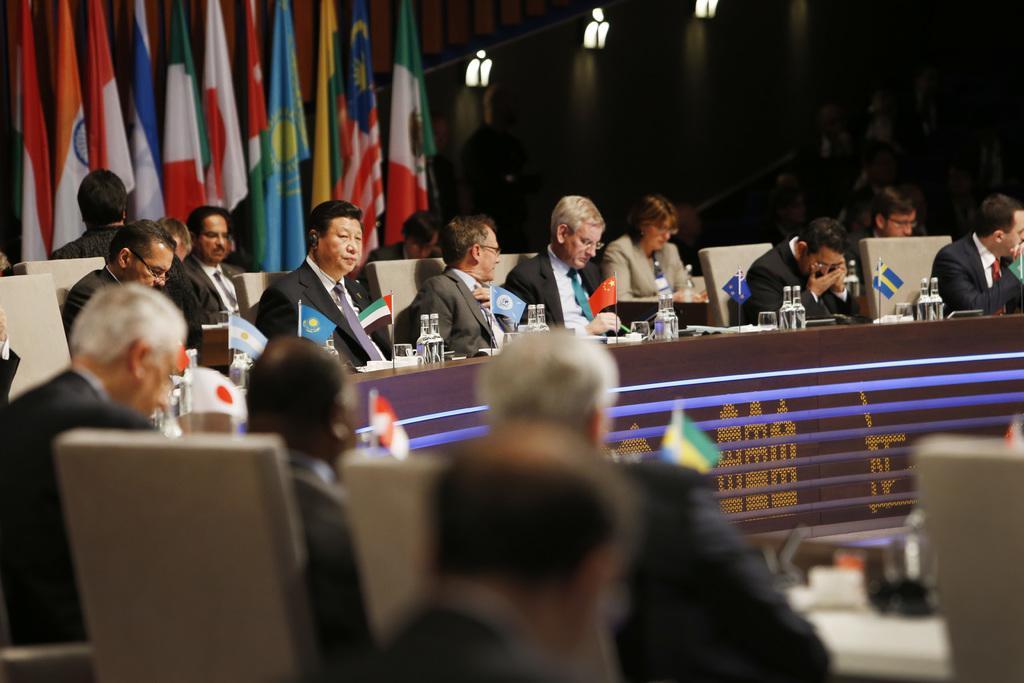Could you give a brief overview of what you see in this image? In this image we can see a group of people sitting on the chairs beside a table containing some bottles, glasses, flags and some objects placed on it. On the backside we can see some flags, a group of people and some lights. 